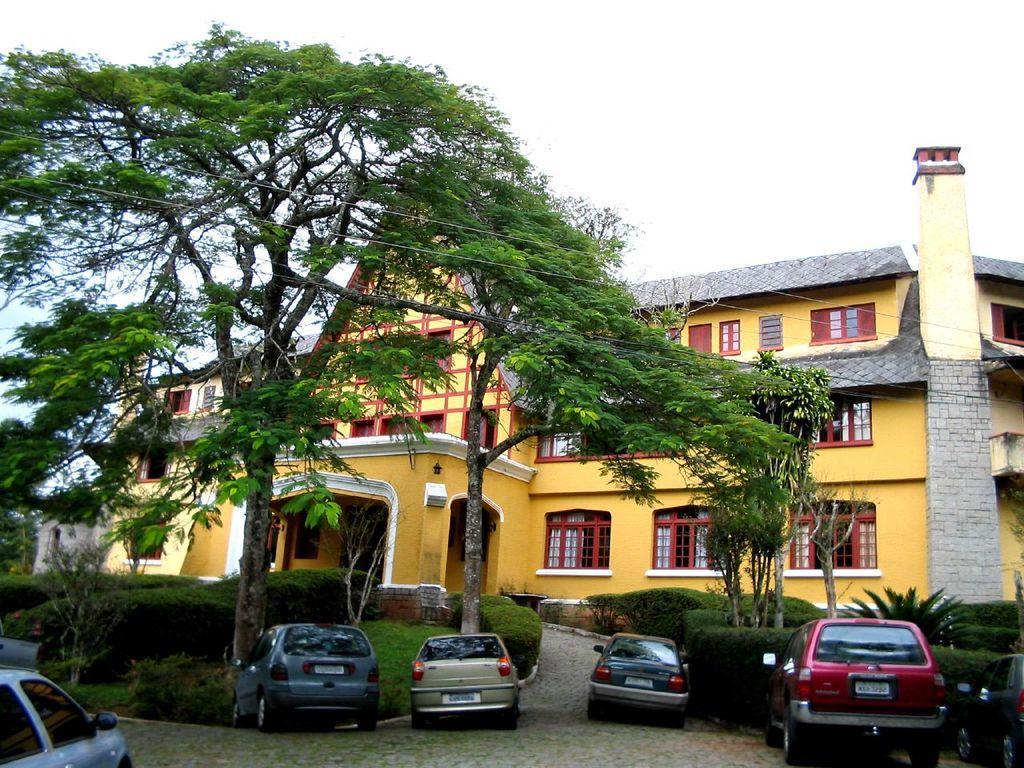Please provide a concise description of this image. In the image we can see the building and these are the windows of the building. There are even vehicles and trees. Here we can see the grass, plants, electric wires and the white sky. 